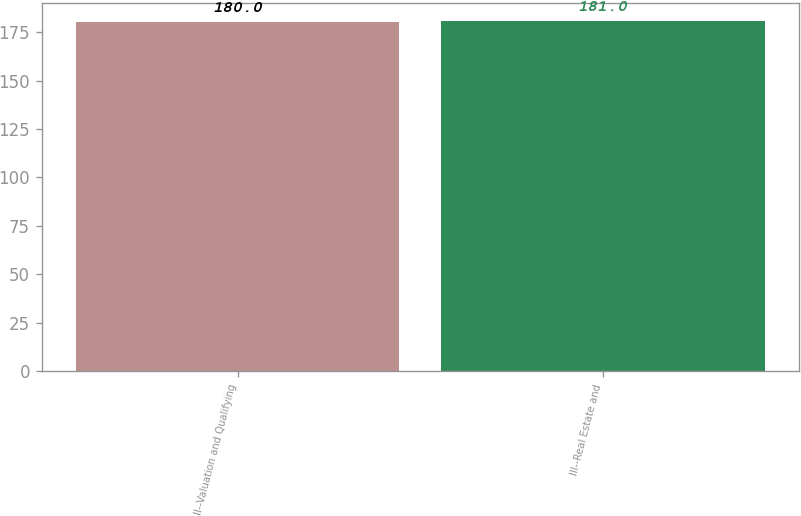Convert chart. <chart><loc_0><loc_0><loc_500><loc_500><bar_chart><fcel>II--Valuation and Qualifying<fcel>III--Real Estate and<nl><fcel>180<fcel>181<nl></chart> 